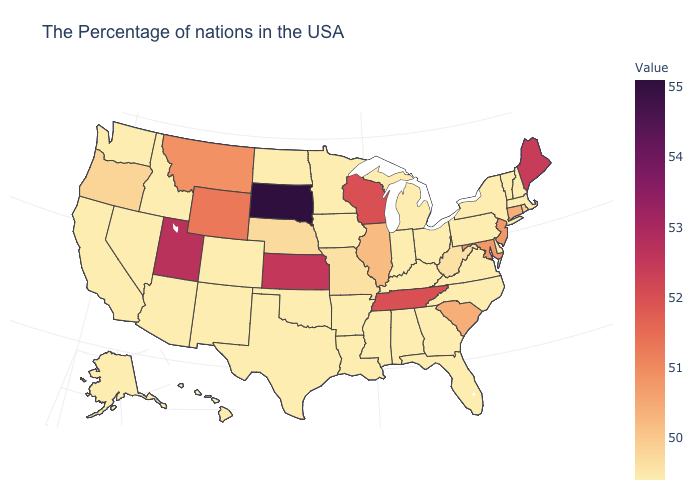Is the legend a continuous bar?
Keep it brief. Yes. Is the legend a continuous bar?
Keep it brief. Yes. Which states have the lowest value in the USA?
Answer briefly. Massachusetts, New Hampshire, Vermont, New York, Delaware, Pennsylvania, Virginia, North Carolina, Ohio, Florida, Georgia, Michigan, Kentucky, Indiana, Alabama, Mississippi, Louisiana, Arkansas, Minnesota, Iowa, Oklahoma, Texas, North Dakota, Colorado, New Mexico, Arizona, Idaho, Nevada, California, Washington, Alaska, Hawaii. Among the states that border West Virginia , does Ohio have the highest value?
Concise answer only. No. Which states hav the highest value in the West?
Quick response, please. Utah. Does New Hampshire have the lowest value in the Northeast?
Be succinct. Yes. 